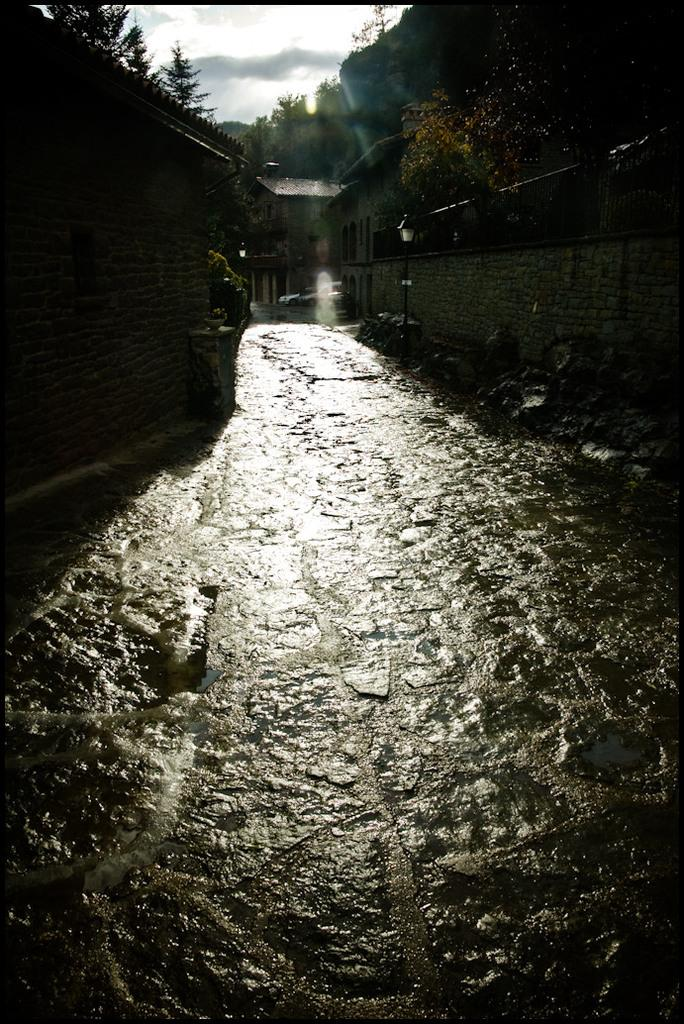What is the condition of the ground in the image? The ground is wet in the image. What structures can be seen in the image? There are light poles, walls, and buildings visible in the image. What can be seen in the background of the image? There are trees and buildings in the background of the image. How would you describe the sky in the image? The sky is cloudy in the image. What type of apparel is the tree wearing in the image? Trees do not wear apparel, so this question cannot be answered. 